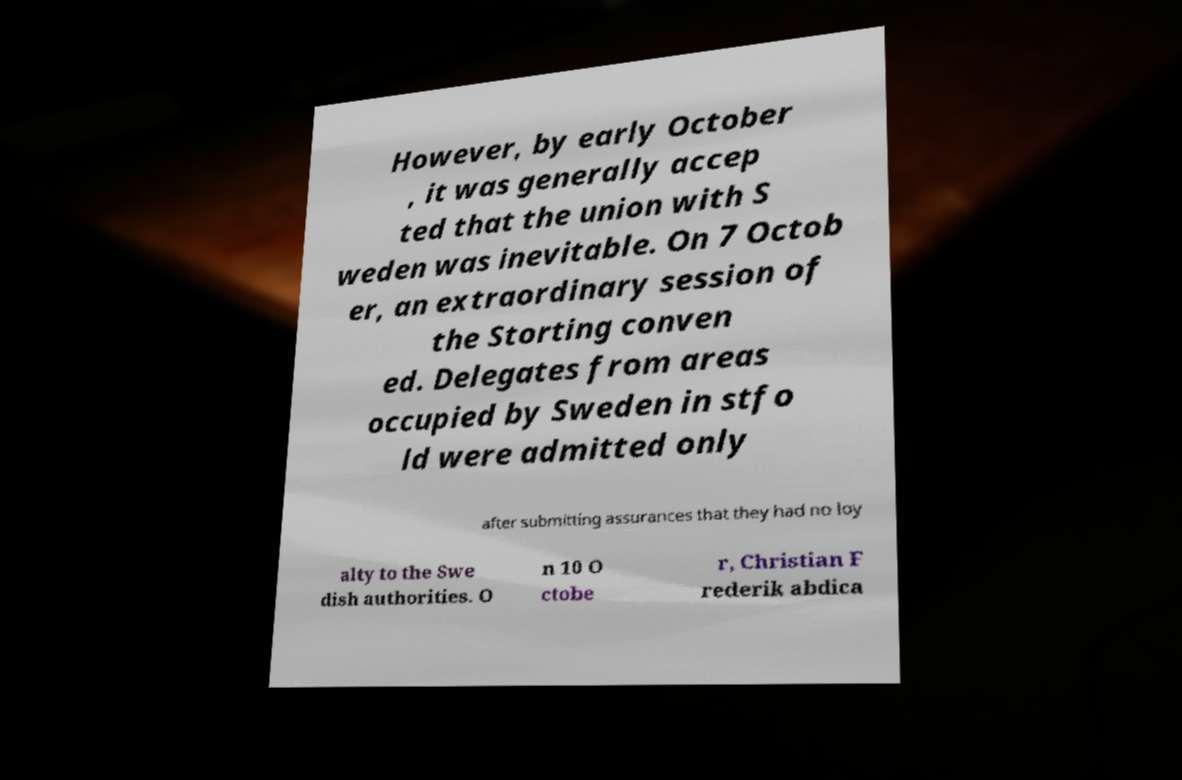Please read and relay the text visible in this image. What does it say? However, by early October , it was generally accep ted that the union with S weden was inevitable. On 7 Octob er, an extraordinary session of the Storting conven ed. Delegates from areas occupied by Sweden in stfo ld were admitted only after submitting assurances that they had no loy alty to the Swe dish authorities. O n 10 O ctobe r, Christian F rederik abdica 